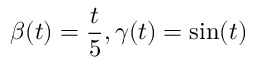Convert formula to latex. <formula><loc_0><loc_0><loc_500><loc_500>\beta ( t ) = \frac { t } { 5 } , \gamma ( t ) = \sin ( t )</formula> 